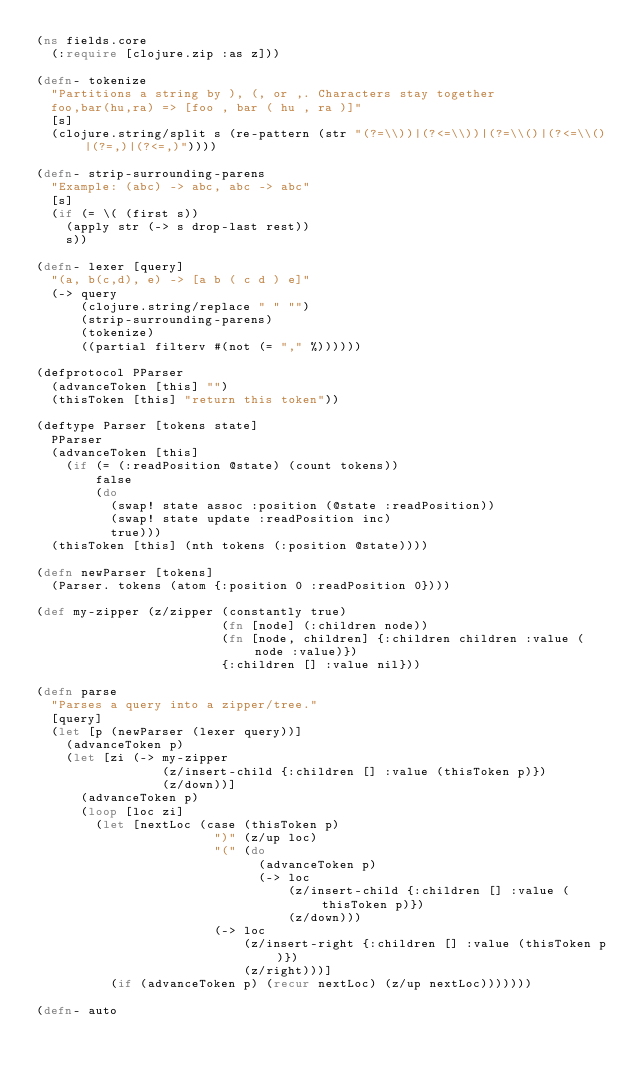<code> <loc_0><loc_0><loc_500><loc_500><_Clojure_>(ns fields.core
  (:require [clojure.zip :as z]))

(defn- tokenize
  "Partitions a string by ), (, or ,. Characters stay together
  foo,bar(hu,ra) => [foo , bar ( hu , ra )]"
  [s]
  (clojure.string/split s (re-pattern (str "(?=\\))|(?<=\\))|(?=\\()|(?<=\\()|(?=,)|(?<=,)"))))

(defn- strip-surrounding-parens
  "Example: (abc) -> abc, abc -> abc"
  [s]
  (if (= \( (first s))
    (apply str (-> s drop-last rest))
    s))

(defn- lexer [query]
  "(a, b(c,d), e) -> [a b ( c d ) e]"
  (-> query
      (clojure.string/replace " " "")
      (strip-surrounding-parens)
      (tokenize)
      ((partial filterv #(not (= "," %))))))

(defprotocol PParser
  (advanceToken [this] "")
  (thisToken [this] "return this token"))

(deftype Parser [tokens state]
  PParser
  (advanceToken [this]
    (if (= (:readPosition @state) (count tokens))
        false
        (do
          (swap! state assoc :position (@state :readPosition))
          (swap! state update :readPosition inc)
          true)))
  (thisToken [this] (nth tokens (:position @state))))

(defn newParser [tokens]
  (Parser. tokens (atom {:position 0 :readPosition 0})))

(def my-zipper (z/zipper (constantly true)
                         (fn [node] (:children node))
                         (fn [node, children] {:children children :value (node :value)})
                         {:children [] :value nil}))

(defn parse
  "Parses a query into a zipper/tree."
  [query]
  (let [p (newParser (lexer query))]
    (advanceToken p)
    (let [zi (-> my-zipper
                 (z/insert-child {:children [] :value (thisToken p)})
                 (z/down))]
      (advanceToken p)
      (loop [loc zi]
        (let [nextLoc (case (thisToken p)
                        ")" (z/up loc)
                        "(" (do
                              (advanceToken p)
                              (-> loc
                                  (z/insert-child {:children [] :value (thisToken p)})
                                  (z/down)))
                        (-> loc
                            (z/insert-right {:children [] :value (thisToken p)})
                            (z/right)))]
          (if (advanceToken p) (recur nextLoc) (z/up nextLoc)))))))

(defn- auto</code> 